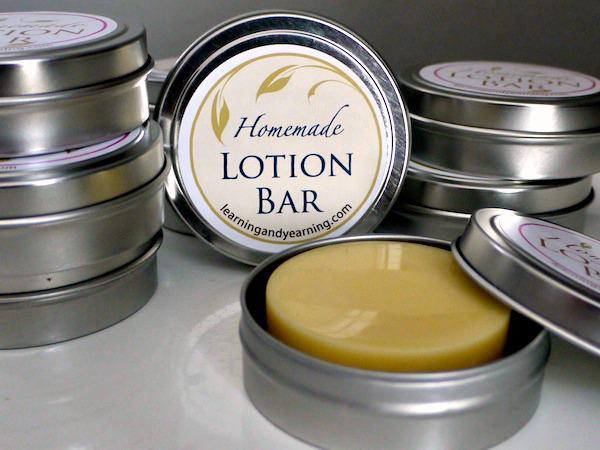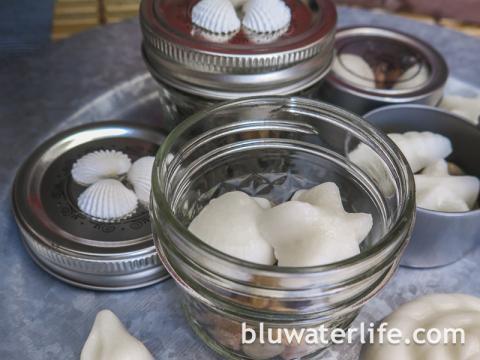The first image is the image on the left, the second image is the image on the right. Assess this claim about the two images: "An image includes multiple stacks of short silver containers with labels on top, and with only one unlidded.". Correct or not? Answer yes or no. Yes. The first image is the image on the left, the second image is the image on the right. Evaluate the accuracy of this statement regarding the images: "The lotion in one of the images is sitting in round tin containers.". Is it true? Answer yes or no. Yes. 